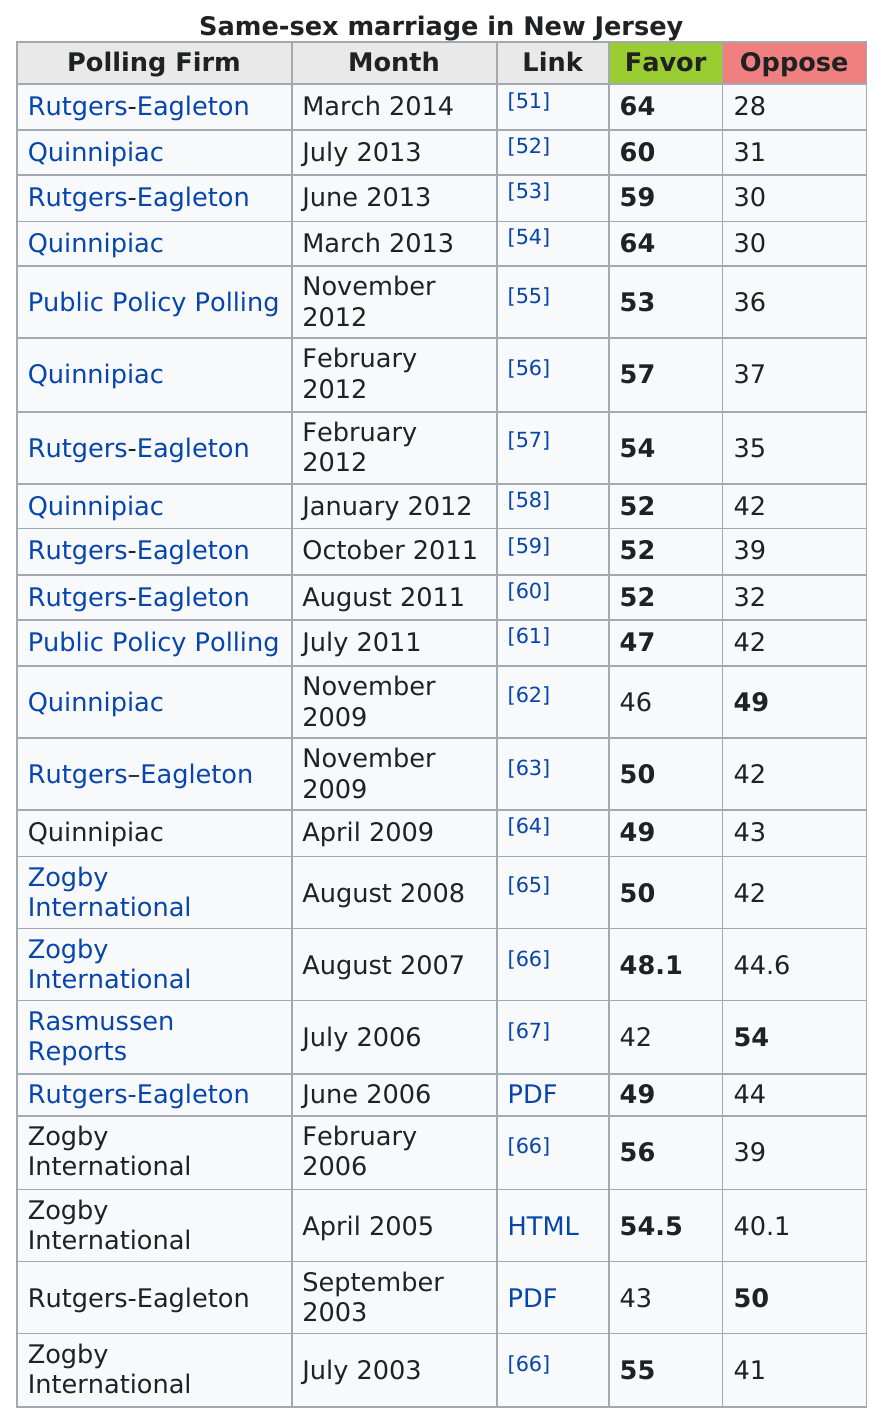Point out several critical features in this image. Out of the months that received more than 55 favor votes, how many had more than 55 favor votes? The person who received the most opposing votes from Quinnipiac in February 2012 and July 2013 was not the same person. In February 2012, the person who received the most opposing votes from Quinnipiac was not the same person who received the most opposing votes from Quinnipiac in July 2013. In 2006, Zogby International was the only polling firm to show more than 50 percent of support for same-sex marriage. In March 2014, Rutgers Eagleton gave 64 votes in favor. In 2011, Public Policy Polling was the polling firm with the least amount of favorable votes. 